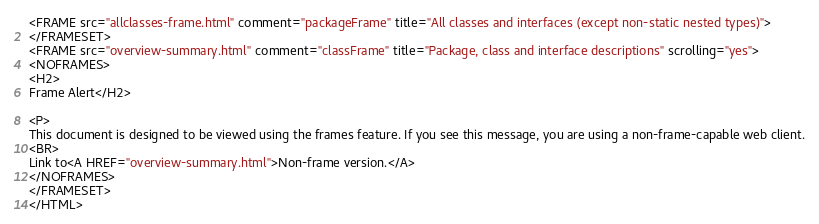<code> <loc_0><loc_0><loc_500><loc_500><_HTML_><FRAME src="allclasses-frame.html" comment="packageFrame" title="All classes and interfaces (except non-static nested types)">
</FRAMESET>
<FRAME src="overview-summary.html" comment="classFrame" title="Package, class and interface descriptions" scrolling="yes">
<NOFRAMES>
<H2>
Frame Alert</H2>

<P>
This document is designed to be viewed using the frames feature. If you see this message, you are using a non-frame-capable web client.
<BR>
Link to<A HREF="overview-summary.html">Non-frame version.</A>
</NOFRAMES>
</FRAMESET>
</HTML>
</code> 